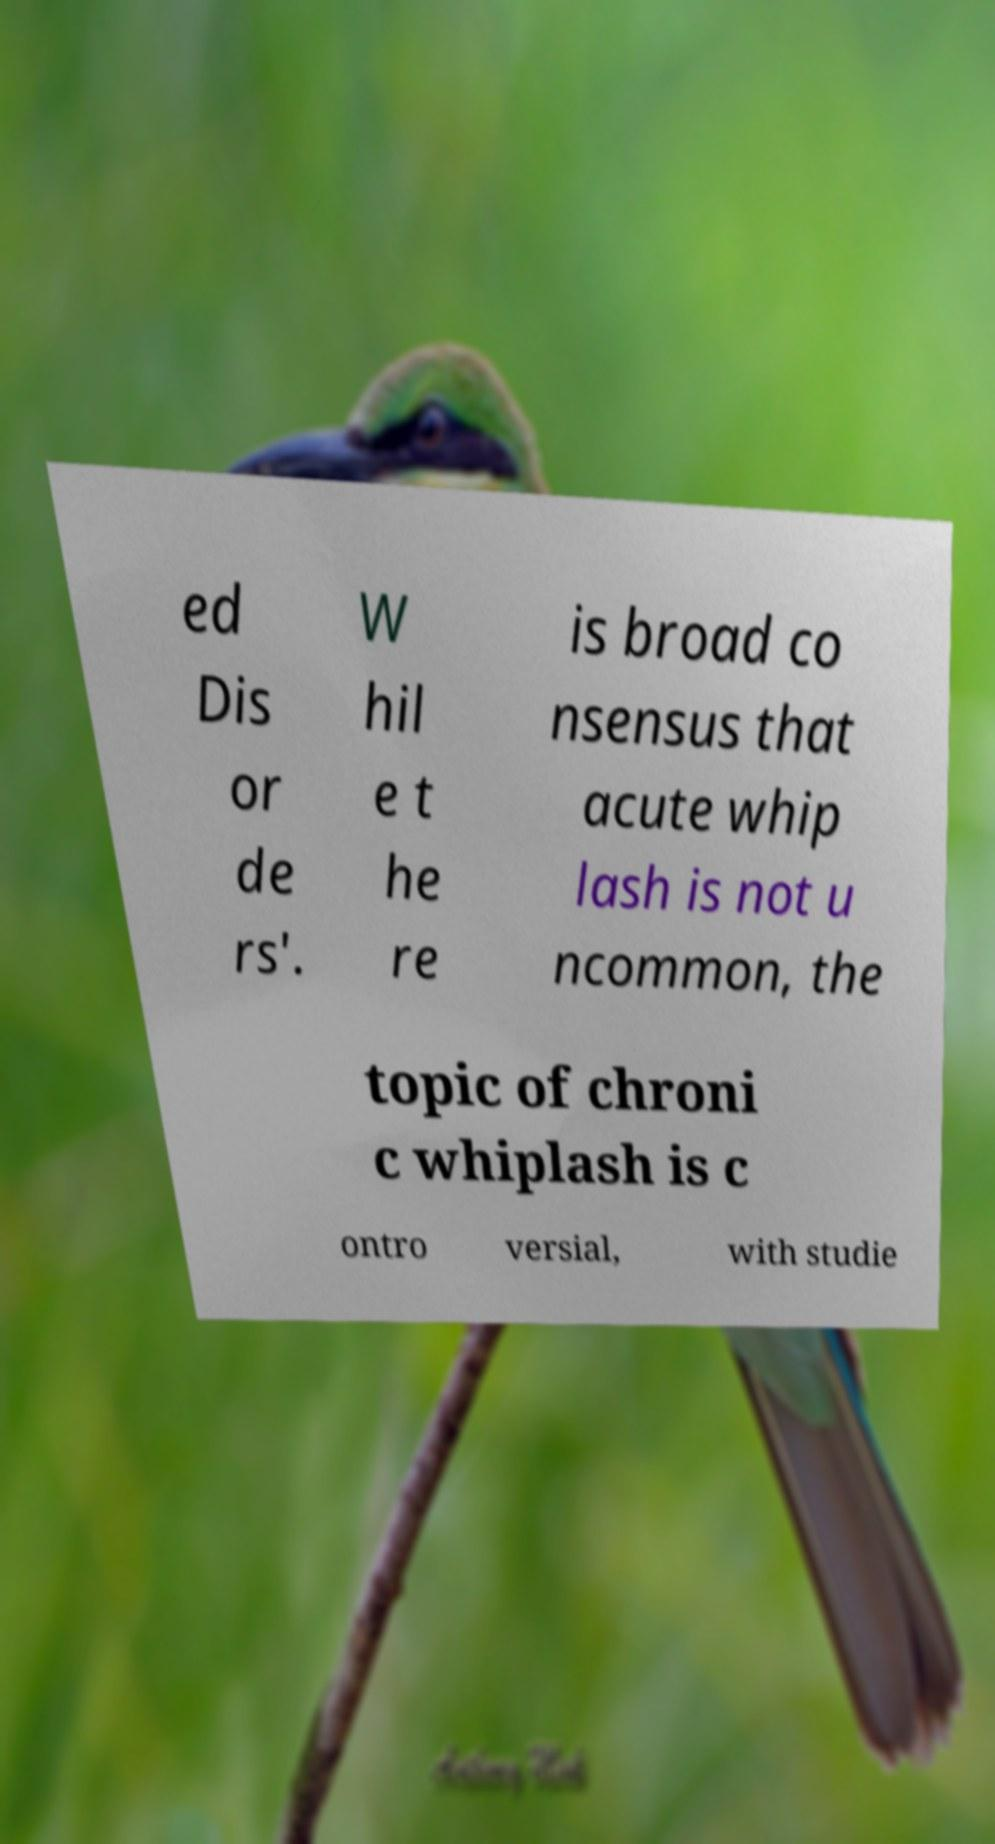I need the written content from this picture converted into text. Can you do that? ed Dis or de rs'. W hil e t he re is broad co nsensus that acute whip lash is not u ncommon, the topic of chroni c whiplash is c ontro versial, with studie 